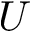<formula> <loc_0><loc_0><loc_500><loc_500>U</formula> 